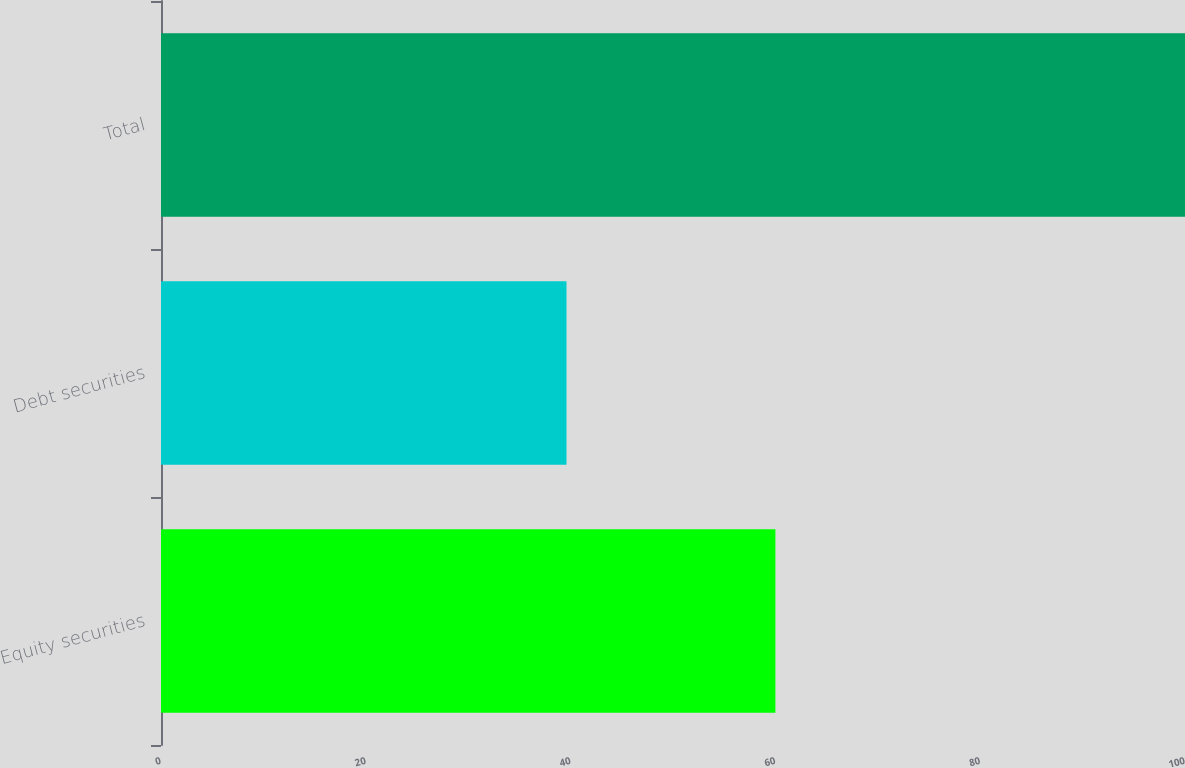<chart> <loc_0><loc_0><loc_500><loc_500><bar_chart><fcel>Equity securities<fcel>Debt securities<fcel>Total<nl><fcel>60<fcel>39.6<fcel>100<nl></chart> 